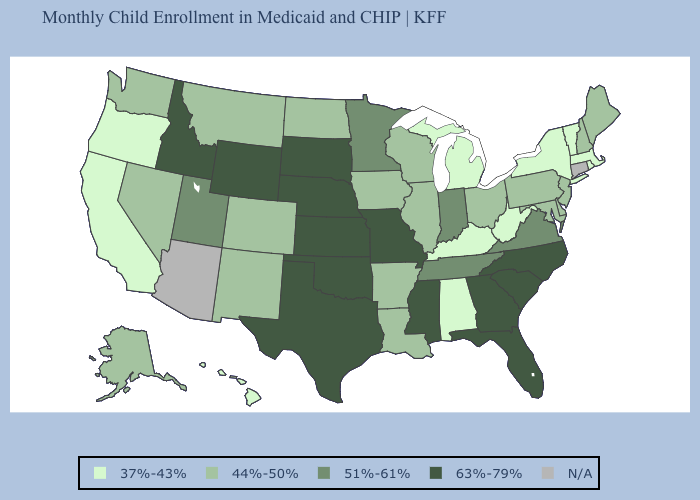Name the states that have a value in the range 51%-61%?
Concise answer only. Indiana, Minnesota, Tennessee, Utah, Virginia. Among the states that border Louisiana , which have the highest value?
Give a very brief answer. Mississippi, Texas. What is the value of Tennessee?
Short answer required. 51%-61%. Name the states that have a value in the range 44%-50%?
Give a very brief answer. Alaska, Arkansas, Colorado, Delaware, Illinois, Iowa, Louisiana, Maine, Maryland, Montana, Nevada, New Hampshire, New Jersey, New Mexico, North Dakota, Ohio, Pennsylvania, Washington, Wisconsin. What is the value of Idaho?
Short answer required. 63%-79%. Does Maine have the highest value in the Northeast?
Answer briefly. Yes. Which states have the lowest value in the Northeast?
Be succinct. Massachusetts, New York, Rhode Island, Vermont. How many symbols are there in the legend?
Write a very short answer. 5. Does Kentucky have the lowest value in the USA?
Answer briefly. Yes. Name the states that have a value in the range 63%-79%?
Keep it brief. Florida, Georgia, Idaho, Kansas, Mississippi, Missouri, Nebraska, North Carolina, Oklahoma, South Carolina, South Dakota, Texas, Wyoming. What is the lowest value in states that border Delaware?
Concise answer only. 44%-50%. Among the states that border New Hampshire , which have the highest value?
Keep it brief. Maine. Name the states that have a value in the range 51%-61%?
Concise answer only. Indiana, Minnesota, Tennessee, Utah, Virginia. What is the value of New York?
Give a very brief answer. 37%-43%. Name the states that have a value in the range 51%-61%?
Short answer required. Indiana, Minnesota, Tennessee, Utah, Virginia. 